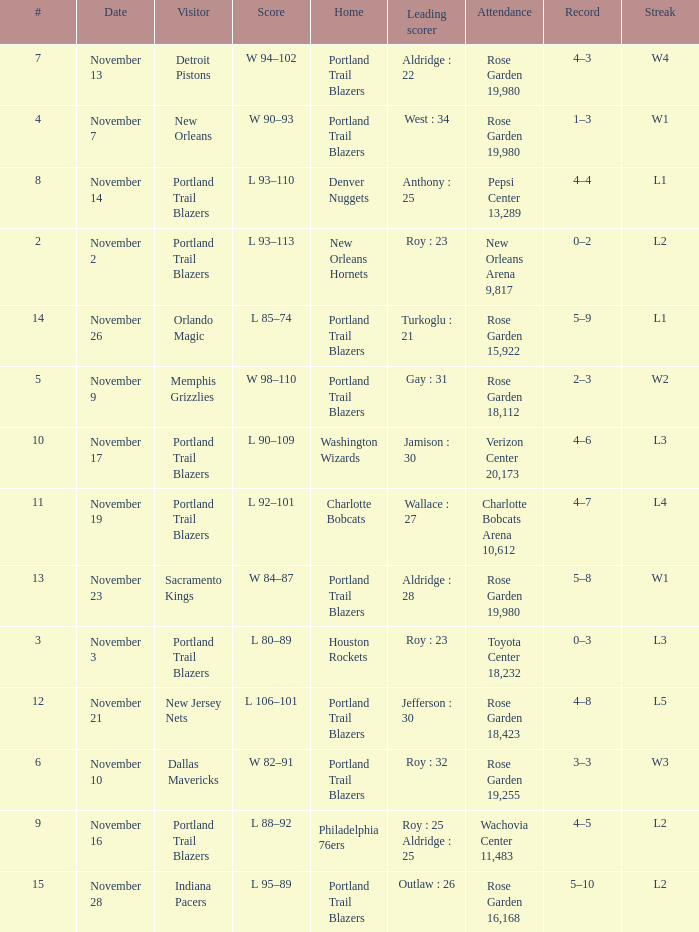What is the total number of record where streak is l2 and leading scorer is roy : 23 1.0. 